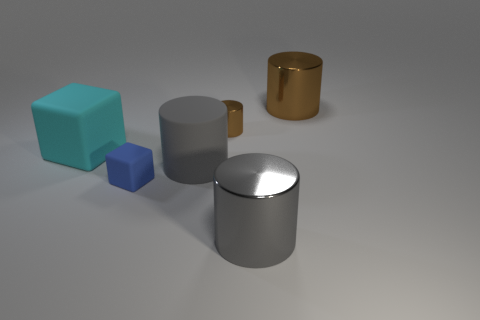What is the color of the rubber object that is in front of the large gray rubber cylinder?
Provide a short and direct response. Blue. How many cyan cubes are in front of the brown cylinder in front of the large object behind the large block?
Ensure brevity in your answer.  1. What is the size of the gray metallic thing?
Provide a short and direct response. Large. What material is the other gray cylinder that is the same size as the gray shiny cylinder?
Offer a terse response. Rubber. What number of blue matte objects are to the left of the large cyan rubber object?
Ensure brevity in your answer.  0. Does the gray cylinder that is right of the big matte cylinder have the same material as the small object in front of the big cyan matte thing?
Your answer should be very brief. No. There is a gray object that is on the right side of the brown metal cylinder on the left side of the big cylinder behind the large cyan rubber object; what shape is it?
Your answer should be compact. Cylinder. The small shiny object is what shape?
Provide a succinct answer. Cylinder. What shape is the other gray object that is the same size as the gray shiny thing?
Your answer should be very brief. Cylinder. What number of other objects are the same color as the tiny block?
Offer a very short reply. 0. 